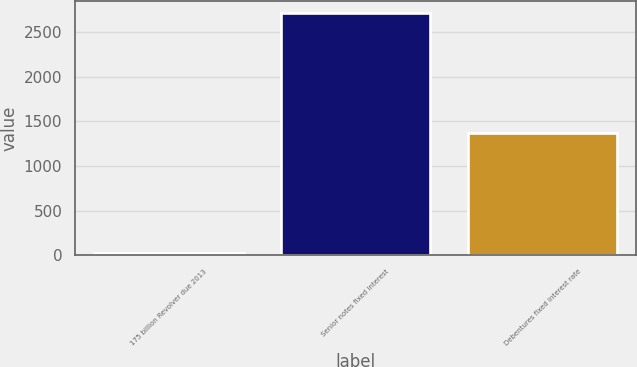Convert chart to OTSL. <chart><loc_0><loc_0><loc_500><loc_500><bar_chart><fcel>175 billion Revolver due 2013<fcel>Senior notes fixed interest<fcel>Debentures fixed interest rate<nl><fcel>25<fcel>2712.44<fcel>1368.72<nl></chart> 